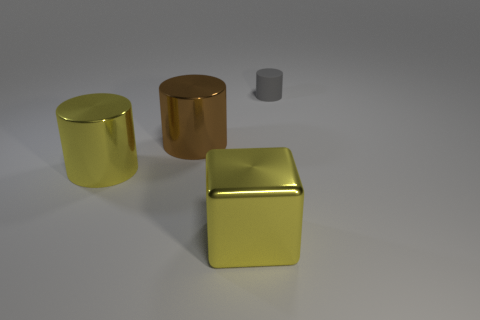How many large cylinders are the same color as the cube?
Your answer should be compact. 1. The other cylinder that is the same material as the big yellow cylinder is what color?
Your response must be concise. Brown. What number of green cylinders are made of the same material as the big brown object?
Offer a very short reply. 0. There is a large shiny object that is behind the yellow metallic thing behind the big metal object in front of the yellow cylinder; what is its color?
Keep it short and to the point. Brown. Do the yellow cylinder and the gray rubber cylinder have the same size?
Offer a very short reply. No. How many objects are big yellow things behind the big metallic block or large yellow shiny objects?
Provide a short and direct response. 2. Do the rubber object and the big brown metallic object have the same shape?
Ensure brevity in your answer.  Yes. How many other objects are the same size as the shiny cube?
Ensure brevity in your answer.  2. The small thing is what color?
Make the answer very short. Gray. How many tiny objects are either brown metallic spheres or matte cylinders?
Offer a terse response. 1. 